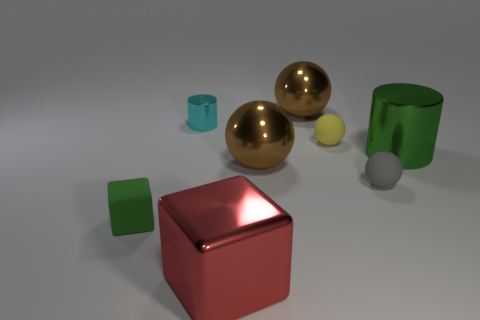Subtract all tiny yellow matte spheres. How many spheres are left? 3 Add 2 tiny yellow rubber cubes. How many objects exist? 10 Subtract all yellow cylinders. How many brown balls are left? 2 Subtract all red blocks. How many blocks are left? 1 Subtract 2 cubes. How many cubes are left? 0 Subtract 0 green spheres. How many objects are left? 8 Subtract all cubes. How many objects are left? 6 Subtract all gray cylinders. Subtract all yellow blocks. How many cylinders are left? 2 Subtract all rubber blocks. Subtract all brown spheres. How many objects are left? 5 Add 1 green rubber objects. How many green rubber objects are left? 2 